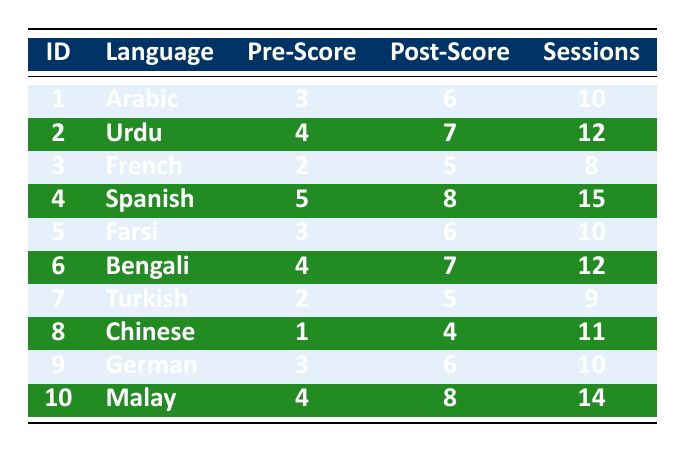What is the Pre-Training Fluency Score for the participant who learned Chinese? The table indicates that the Pre-Training Fluency Score for the participant learning Chinese (Participant_ID 8) is 1.
Answer: 1 Which language had the highest Post-Training Fluency Score? In the table, Spanish has the highest Post-Training Fluency Score of 8, as observed in Participant_ID 4's row.
Answer: Spanish How many training sessions did the participant with the lowest Pre-Training Fluency Score complete? The participant with the lowest Pre-Training Fluency Score is the one who learned Chinese, completing 11 training sessions according to their row in the table.
Answer: 11 What is the difference between the highest and lowest Post-Training Fluency Scores? The highest Post-Training Fluency Score is 8 (Spanish) and the lowest is 4 (Chinese). The difference is 8 - 4 = 4.
Answer: 4 How many participants increased their fluency score by 3 points or more? Participants with score increases of 3 or more include Arabic (3 to 6), Urdu (4 to 7), Spanish (5 to 8), and Malay (4 to 8), totaling 4 participants.
Answer: 4 What was the average Pre-Training Fluency Score across all participants? The total of all Pre-Training Fluency Scores is 3 + 4 + 2 + 5 + 3 + 4 + 2 + 1 + 3 + 4 = 31. There are 10 participants, so the average is 31/10 = 3.1.
Answer: 3.1 Is it true that all participants completed more than 8 training sessions? By examining the table, participants who learned French and Turkish completed 8 and 9 sessions, respectively, which means not all participants completed more than 8 sessions.
Answer: No Which language improvement (Post-Training Score minus Pre-Training Score) was the greatest? The improvements are calculated as follows: Arabic (3), Urdu (3), Spanish (3), Farsi (3), Bengali (3), Turkish (3), Chinese (3), German (3), Malay (4). The highest improvement is 4 (Malay).
Answer: Malay What is the average number of training sessions completed by all participants? The sum of the training sessions is 10 + 12 + 8 + 15 + 10 + 12 + 9 + 11 + 10 + 14 = 121. Dividing by 10 participants yields an average of 121/10 = 12.1.
Answer: 12.1 What percentage of participants had a Post-Training Fluency Score of 7 or higher? The participants with scores of 7 or higher are Urdu, Spanish, Bengali, and Malay, totaling 4 out of 10 participants, giving a percentage of (4/10)*100 = 40%.
Answer: 40% 